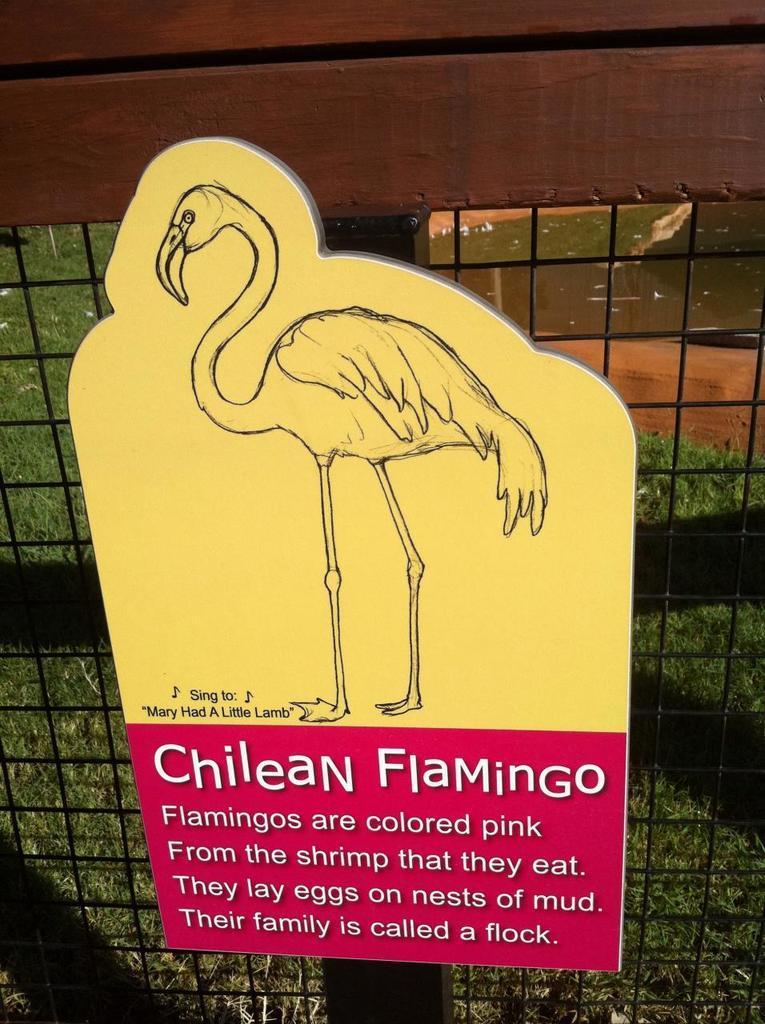Could you give a brief overview of what you see in this image? In this picture we can observe yellow and red color board. We can observe a flamingo on the yellow color board. There is some text on the board. In the background we can observe a door. 